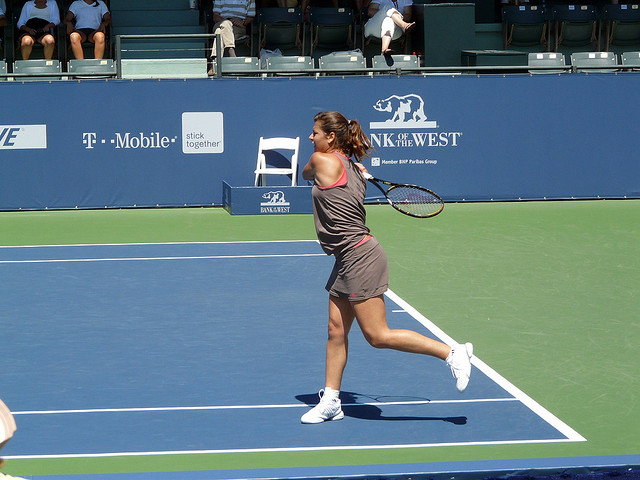Extract all visible text content from this image. NK WEST Mobile stick THE of together IE 